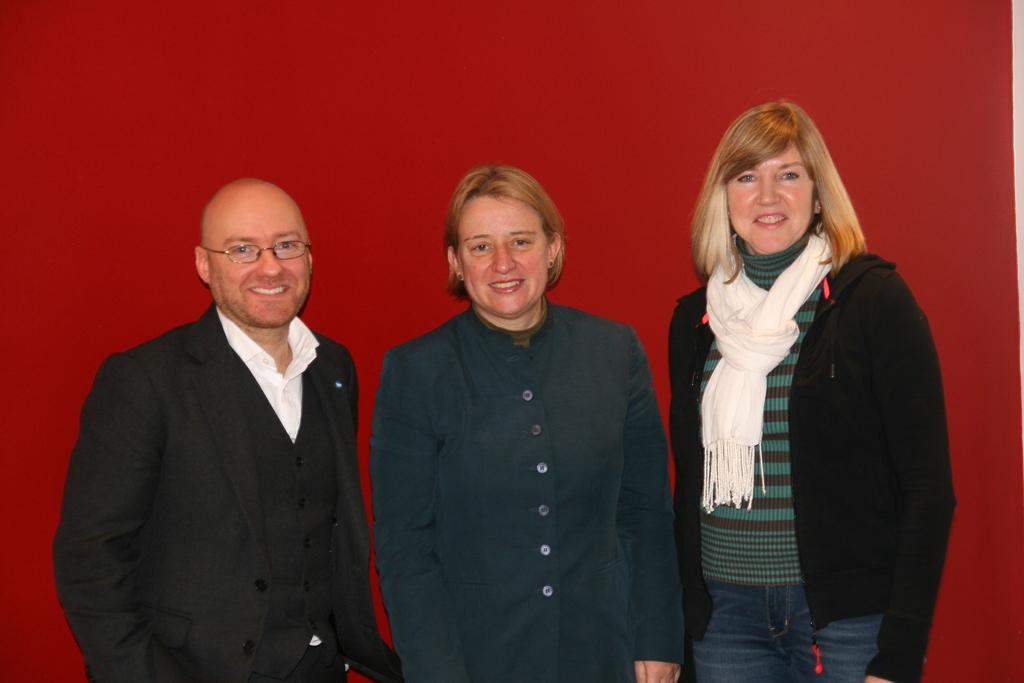How many people are present in the image? There are three people in the image. What expressions do the people have on their faces? The people are wearing smiles on their faces. What can be seen in the background of the image? There is a wall in the background of the image. What type of jellyfish can be seen swimming near the people in the image? There are no jellyfish present in the image; it features three people with smiling faces and a wall in the background. 